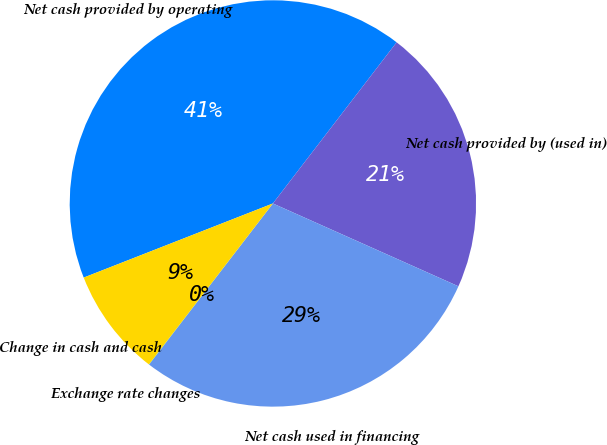<chart> <loc_0><loc_0><loc_500><loc_500><pie_chart><fcel>Net cash provided by operating<fcel>Net cash provided by (used in)<fcel>Net cash used in financing<fcel>Exchange rate changes<fcel>Change in cash and cash<nl><fcel>41.36%<fcel>21.26%<fcel>28.74%<fcel>0.02%<fcel>8.61%<nl></chart> 